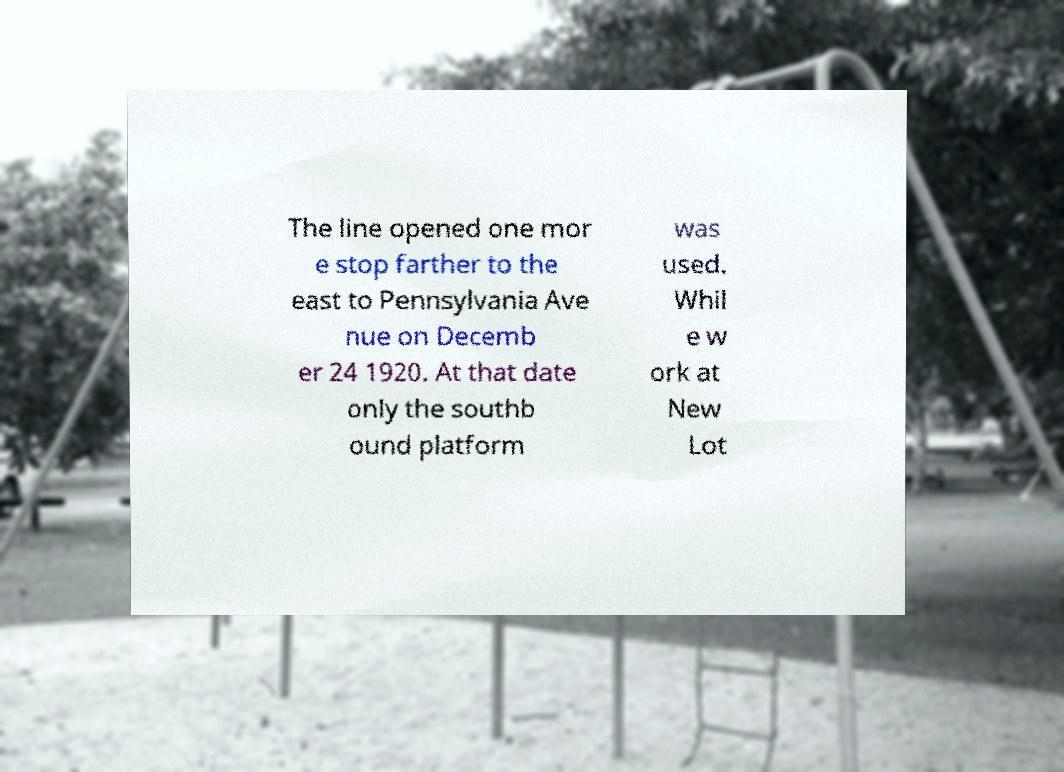Please read and relay the text visible in this image. What does it say? The line opened one mor e stop farther to the east to Pennsylvania Ave nue on Decemb er 24 1920. At that date only the southb ound platform was used. Whil e w ork at New Lot 